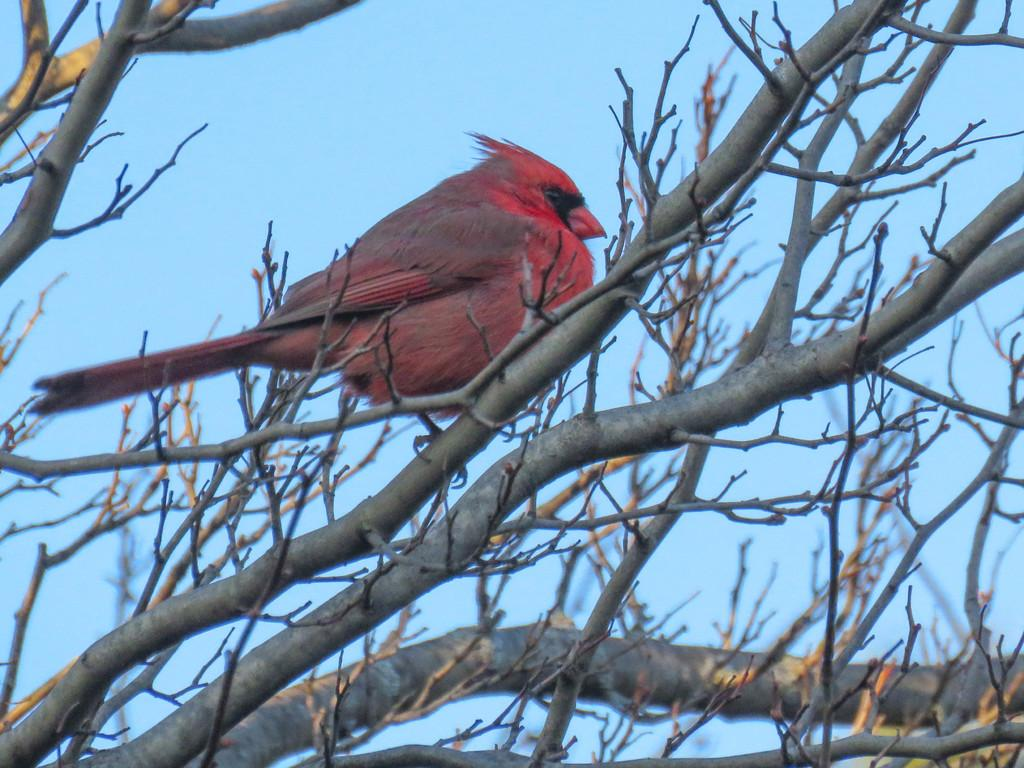What type of animal is in the image? There is a bird in the image. What color is the bird? The bird is red in color. Where is the bird located in the image? The bird is sitting on a stem of a tree. What is the condition of the tree at the bottom of the image? The tree at the bottom of the image is dried. What can be seen in the background of the image? The sky is visible in the background of the image. How many clovers are growing around the bird in the image? There are no clovers present in the image. What season is depicted in the image, given the presence of spring flowers? There is no mention of spring flowers in the image, so it cannot be determined from the image alone. 